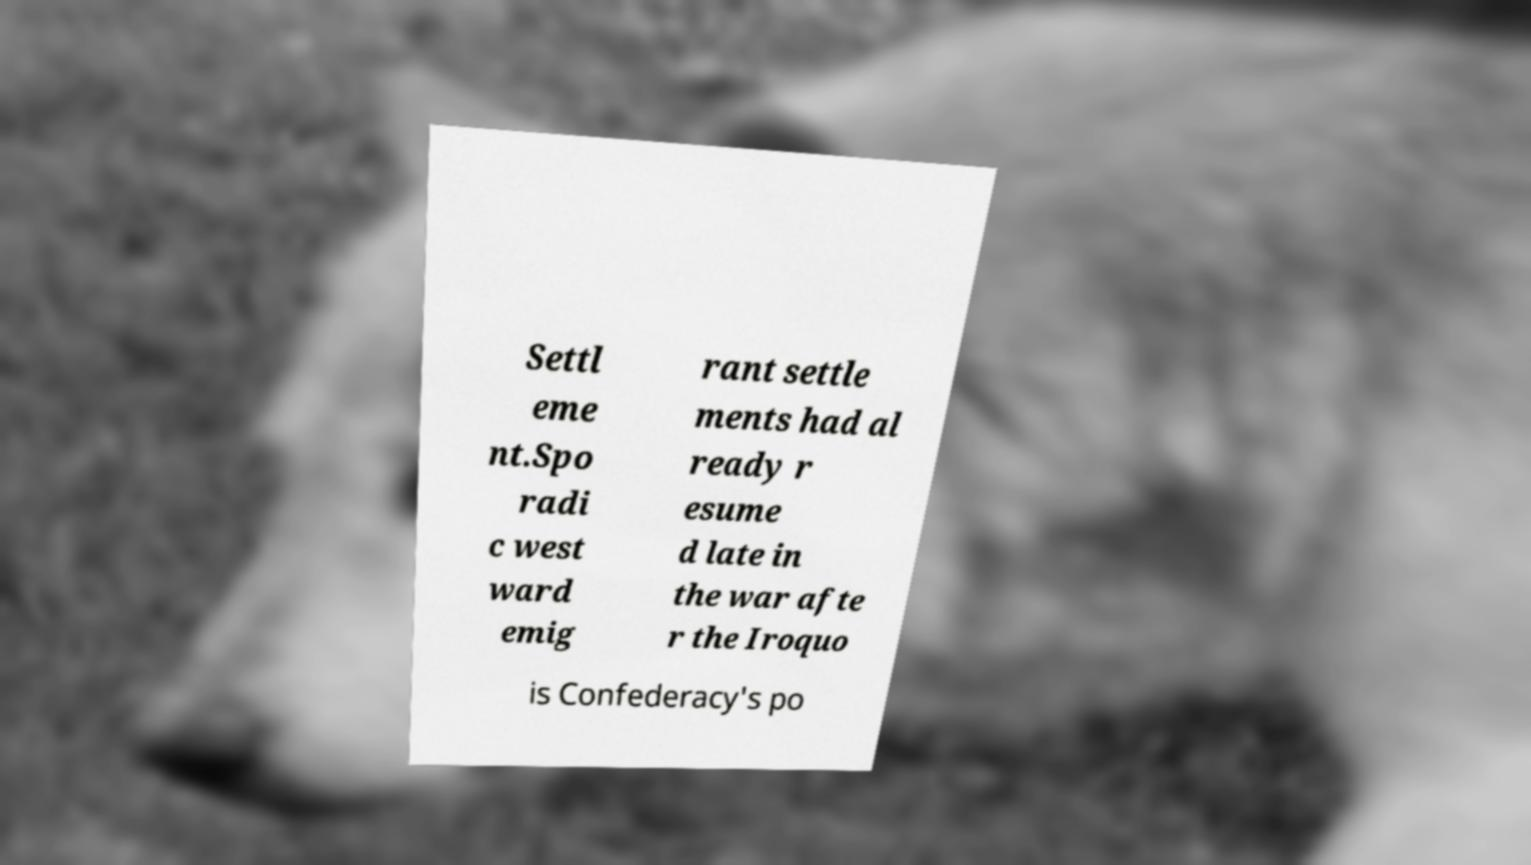There's text embedded in this image that I need extracted. Can you transcribe it verbatim? Settl eme nt.Spo radi c west ward emig rant settle ments had al ready r esume d late in the war afte r the Iroquo is Confederacy's po 